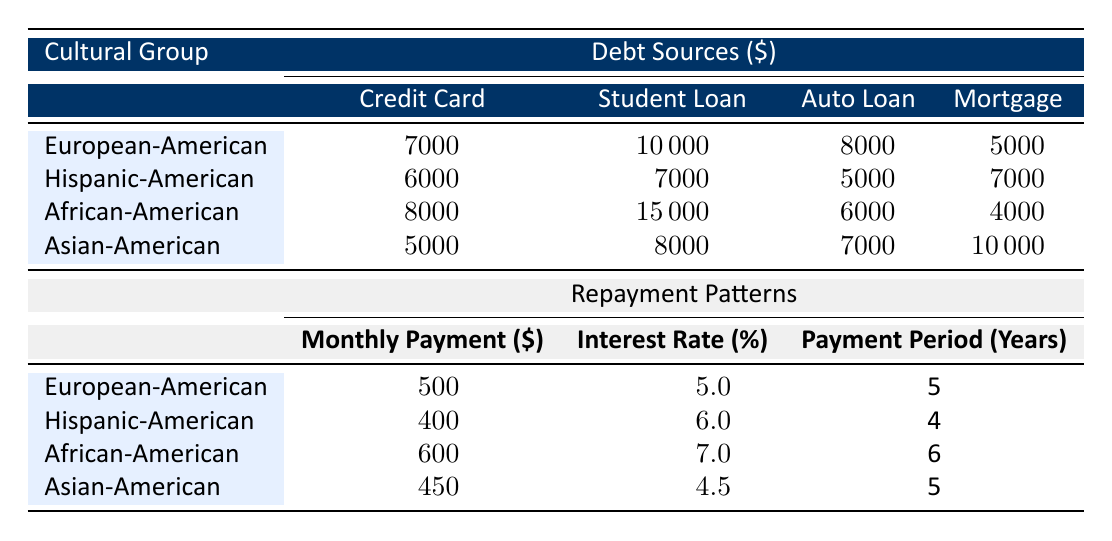What is the average debt for the Hispanic-American cultural group? The table lists the average debt for the Hispanic-American cultural group as 20000.
Answer: 20000 Which cultural group has the highest monthly payment? By examining the repayment patterns, the African-American group has a monthly payment of 600, which is higher than the European-American (500), Hispanic-American (400), and Asian-American (450) groups.
Answer: African-American Are student loans a significant source of debt for the African-American group compared to other groups? The African-American group has the highest amount in student loans at 15000, which is significantly higher than Hispanic-American (7000), Asian-American (8000), and European-American (10000) groups, indicating a heavier reliance on student loans relative to other debt sources.
Answer: Yes What is the total amount of debt sources for the Asian-American cultural group? Summing the debt sources for the Asian-American group gives: 5000 (credit card) + 8000 (student loan) + 7000 (auto loan) + 10000 (mortgage) = 30000. Therefore, the total amount of debt sources is 30000.
Answer: 30000 What is the combined average debt of the European-American and Asian-American groups? The combined average debt can be calculated by adding the average debts: European-American (25000) + Asian-American (22000) = 47000, thus the combined average debt for these two groups is 47000.
Answer: 47000 Is the total debt from credit cards for the African-American group more than that for the Hispanic-American group? The African-American group has 8000 from credit cards, while the Hispanic-American group has 6000. Since 8000 is greater than 6000, the total debt from credit cards for the African-American group is more.
Answer: Yes What is the difference in average debt between the African-American and Hispanic-American groups? To find the difference, subtract the average debt of the Hispanic-American group (20000) from that of the African-American group (30000): 30000 - 20000 = 10000. This shows that the African-American group has 10000 more in average debt compared to the Hispanic-American group.
Answer: 10000 